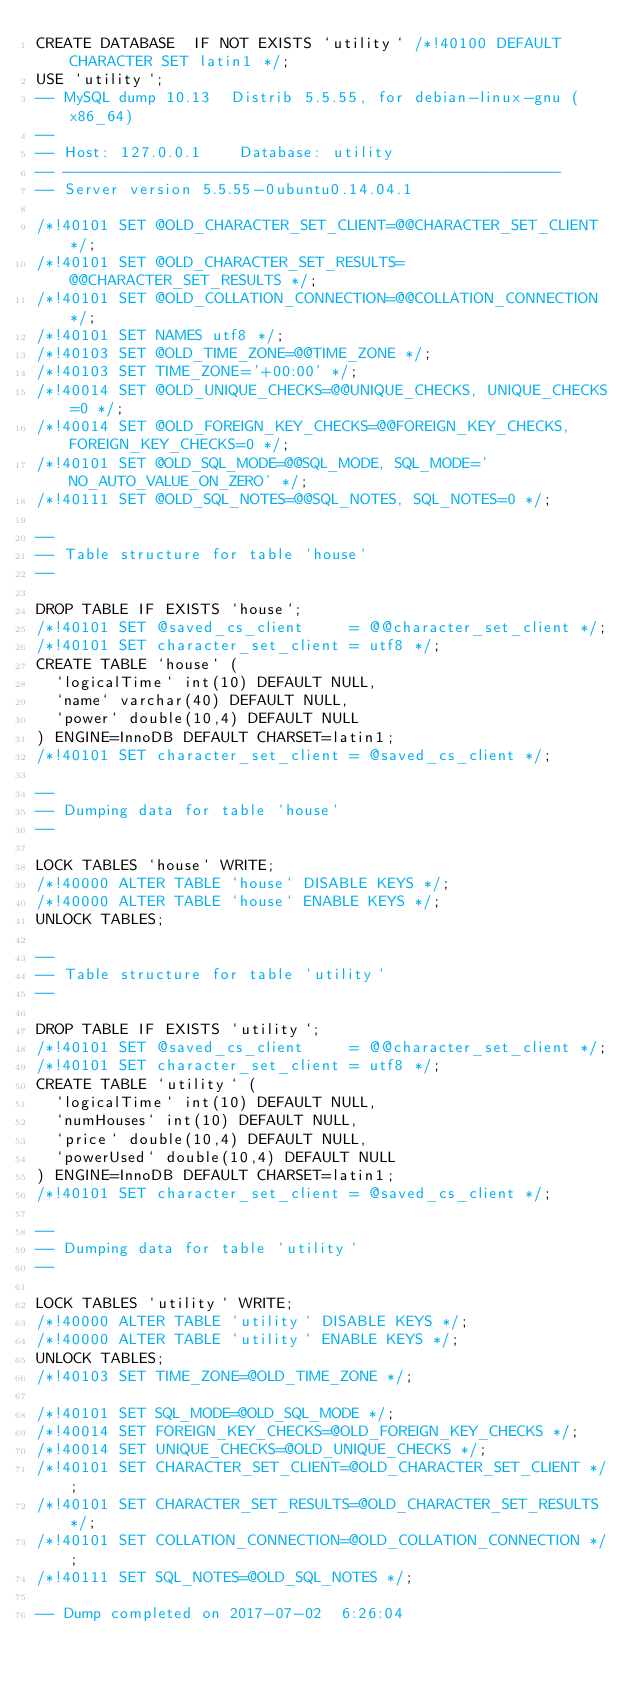<code> <loc_0><loc_0><loc_500><loc_500><_SQL_>CREATE DATABASE  IF NOT EXISTS `utility` /*!40100 DEFAULT CHARACTER SET latin1 */;
USE `utility`;
-- MySQL dump 10.13  Distrib 5.5.55, for debian-linux-gnu (x86_64)
--
-- Host: 127.0.0.1    Database: utility
-- ------------------------------------------------------
-- Server version	5.5.55-0ubuntu0.14.04.1

/*!40101 SET @OLD_CHARACTER_SET_CLIENT=@@CHARACTER_SET_CLIENT */;
/*!40101 SET @OLD_CHARACTER_SET_RESULTS=@@CHARACTER_SET_RESULTS */;
/*!40101 SET @OLD_COLLATION_CONNECTION=@@COLLATION_CONNECTION */;
/*!40101 SET NAMES utf8 */;
/*!40103 SET @OLD_TIME_ZONE=@@TIME_ZONE */;
/*!40103 SET TIME_ZONE='+00:00' */;
/*!40014 SET @OLD_UNIQUE_CHECKS=@@UNIQUE_CHECKS, UNIQUE_CHECKS=0 */;
/*!40014 SET @OLD_FOREIGN_KEY_CHECKS=@@FOREIGN_KEY_CHECKS, FOREIGN_KEY_CHECKS=0 */;
/*!40101 SET @OLD_SQL_MODE=@@SQL_MODE, SQL_MODE='NO_AUTO_VALUE_ON_ZERO' */;
/*!40111 SET @OLD_SQL_NOTES=@@SQL_NOTES, SQL_NOTES=0 */;

--
-- Table structure for table `house`
--

DROP TABLE IF EXISTS `house`;
/*!40101 SET @saved_cs_client     = @@character_set_client */;
/*!40101 SET character_set_client = utf8 */;
CREATE TABLE `house` (
  `logicalTime` int(10) DEFAULT NULL,
  `name` varchar(40) DEFAULT NULL,
  `power` double(10,4) DEFAULT NULL
) ENGINE=InnoDB DEFAULT CHARSET=latin1;
/*!40101 SET character_set_client = @saved_cs_client */;

--
-- Dumping data for table `house`
--

LOCK TABLES `house` WRITE;
/*!40000 ALTER TABLE `house` DISABLE KEYS */;
/*!40000 ALTER TABLE `house` ENABLE KEYS */;
UNLOCK TABLES;

--
-- Table structure for table `utility`
--

DROP TABLE IF EXISTS `utility`;
/*!40101 SET @saved_cs_client     = @@character_set_client */;
/*!40101 SET character_set_client = utf8 */;
CREATE TABLE `utility` (
  `logicalTime` int(10) DEFAULT NULL,
  `numHouses` int(10) DEFAULT NULL,
  `price` double(10,4) DEFAULT NULL,
  `powerUsed` double(10,4) DEFAULT NULL
) ENGINE=InnoDB DEFAULT CHARSET=latin1;
/*!40101 SET character_set_client = @saved_cs_client */;

--
-- Dumping data for table `utility`
--

LOCK TABLES `utility` WRITE;
/*!40000 ALTER TABLE `utility` DISABLE KEYS */;
/*!40000 ALTER TABLE `utility` ENABLE KEYS */;
UNLOCK TABLES;
/*!40103 SET TIME_ZONE=@OLD_TIME_ZONE */;

/*!40101 SET SQL_MODE=@OLD_SQL_MODE */;
/*!40014 SET FOREIGN_KEY_CHECKS=@OLD_FOREIGN_KEY_CHECKS */;
/*!40014 SET UNIQUE_CHECKS=@OLD_UNIQUE_CHECKS */;
/*!40101 SET CHARACTER_SET_CLIENT=@OLD_CHARACTER_SET_CLIENT */;
/*!40101 SET CHARACTER_SET_RESULTS=@OLD_CHARACTER_SET_RESULTS */;
/*!40101 SET COLLATION_CONNECTION=@OLD_COLLATION_CONNECTION */;
/*!40111 SET SQL_NOTES=@OLD_SQL_NOTES */;

-- Dump completed on 2017-07-02  6:26:04
</code> 